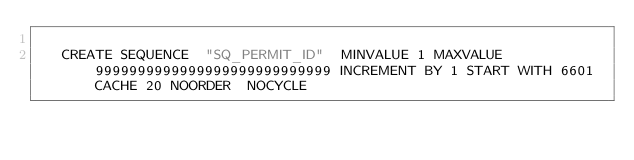<code> <loc_0><loc_0><loc_500><loc_500><_SQL_>
   CREATE SEQUENCE  "SQ_PERMIT_ID"  MINVALUE 1 MAXVALUE 9999999999999999999999999999 INCREMENT BY 1 START WITH 6601 CACHE 20 NOORDER  NOCYCLE </code> 